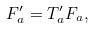<formula> <loc_0><loc_0><loc_500><loc_500>F _ { a } ^ { \prime } = T _ { a } ^ { \prime } F _ { a } ,</formula> 